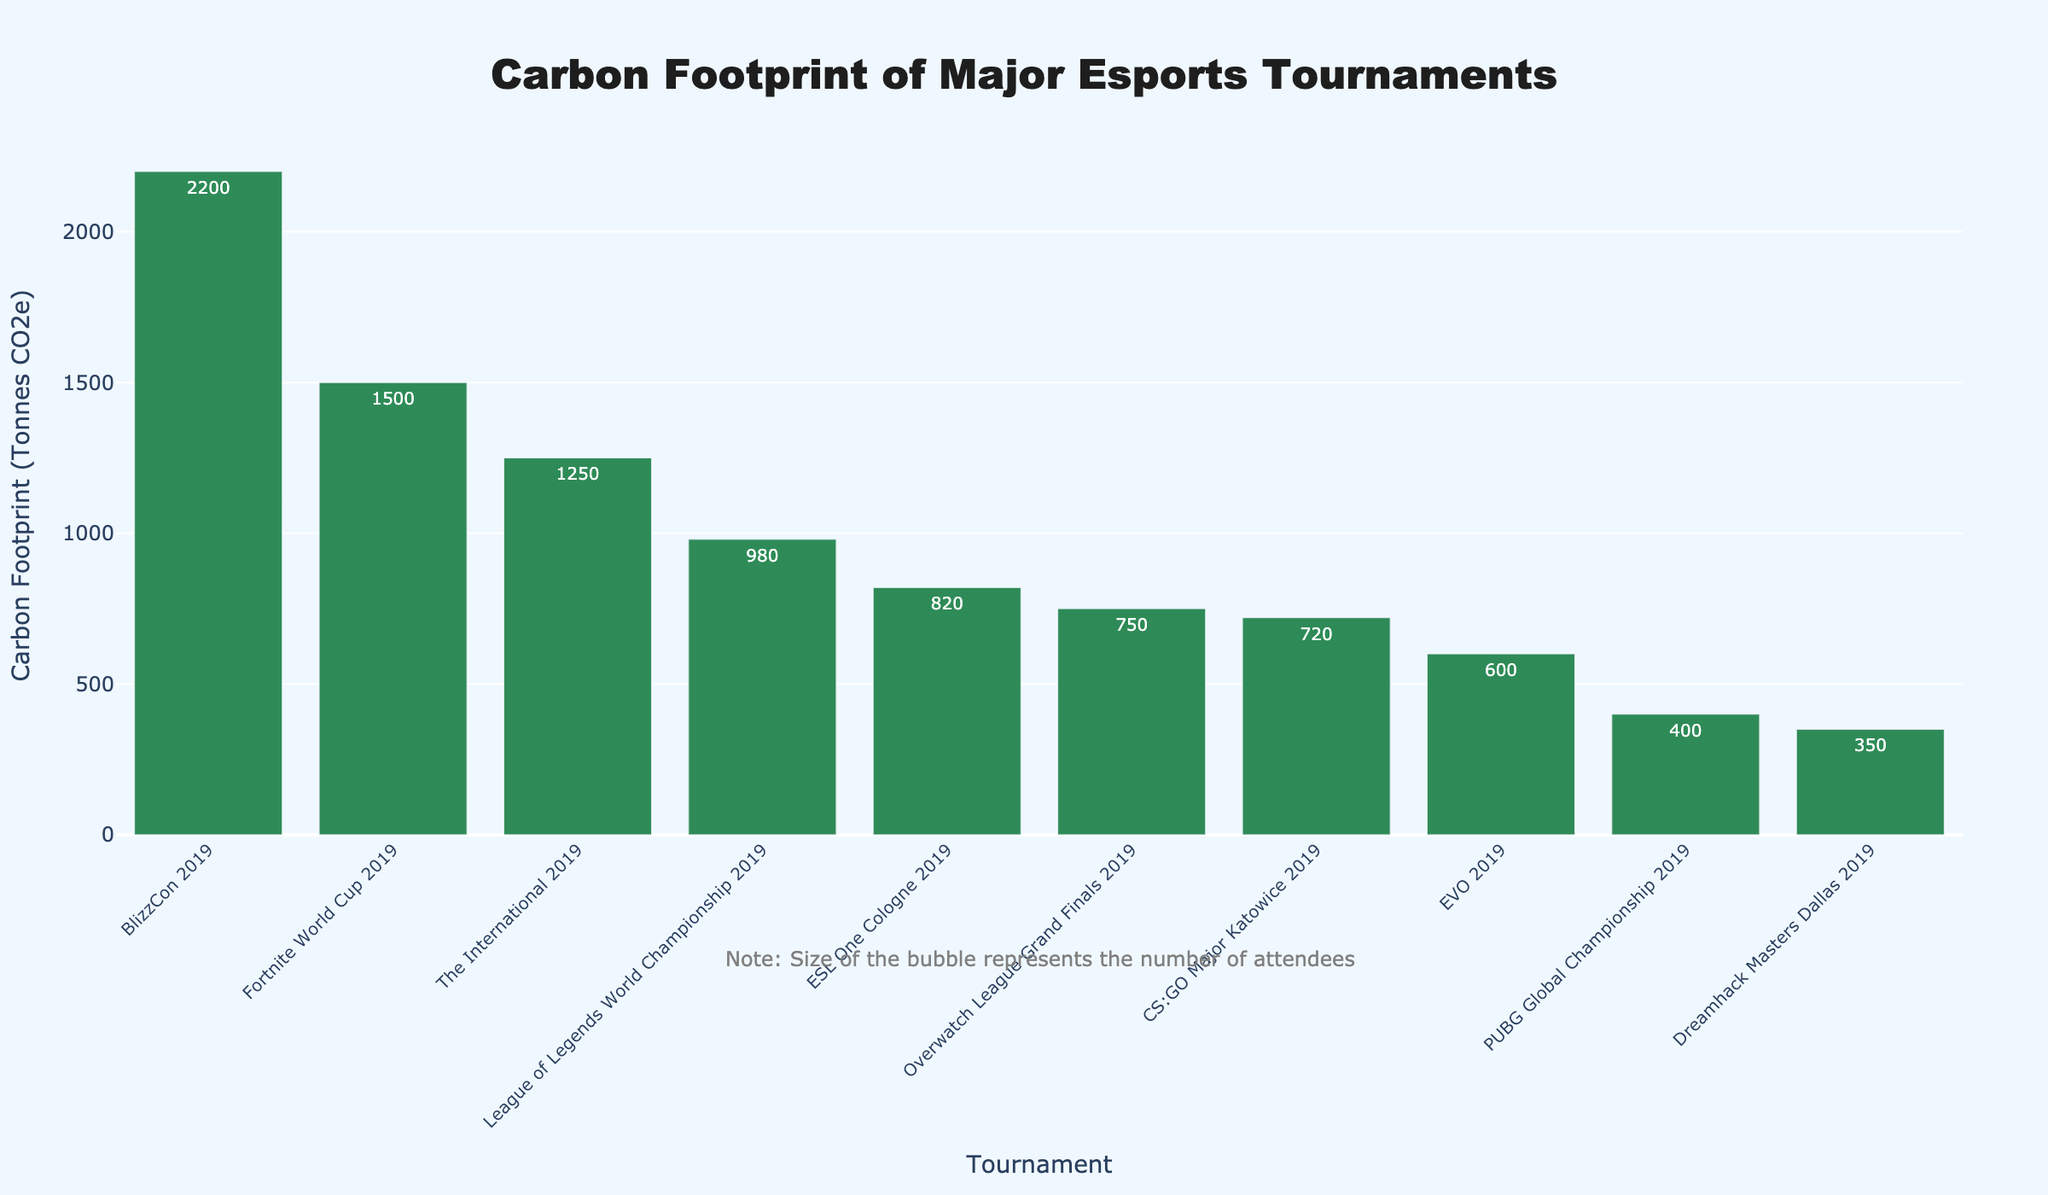Which event has the highest carbon footprint? The event with the highest carbon footprint is BlizzCon 2019, as its bar has the tallest height compared to others.
Answer: BlizzCon 2019 How many attendees were there at the event with the lowest carbon footprint? The event with the lowest carbon footprint is Dreamhack Masters Dallas 2019, which had 350 tonnes CO2e. According to the hover information, it had 5000 attendees.
Answer: 5000 What is the total carbon footprint of events with more than 10,000 attendees? We add the carbon footprints of events with more than 10,000 attendees: BlizzCon 2019 (2200), The International 2019 (1250), League of Legends World Championship 2019 (980), ESL One Cologne 2019 (820), Overwatch League Grand Finals 2019 (750), Fortnite World Cup 2019 (1500), CS:GO Major Katowice 2019 (720). The total sum is 8220 tonnes CO2e.
Answer: 8220 Which event had a higher carbon footprint: EVO 2019 or Overwatch League Grand Finals 2019? Comparing the bars, EVO 2019 had a carbon footprint of 600 tonnes CO2e and Overwatch League Grand Finals 2019 had 750 tonnes CO2e. Overwatch League Grand Finals 2019 had a higher carbon footprint.
Answer: Overwatch League Grand Finals 2019 What is the difference in carbon footprint between the event with the most attendees and the event with the fewest attendees? BlizzCon 2019 had the most attendees with 40,000 and a carbon footprint of 2200 tonnes CO2e. PUBG Global Championship 2019 had the fewest attendees with 6000 and a carbon footprint of 400 tonnes CO2e. The difference is 2200 - 400 = 1800 tonnes CO2e.
Answer: 1800 Which event has a greater carbon footprint relative to its attendees: ESL One Cologne 2019 or The International 2019? For ESL One Cologne 2019: 820 tonnes CO2e / 12000 attendees ≈ 0.0683 tonnes CO2e per attendee. For The International 2019: 1250 tonnes CO2e / 19000 attendees ≈ 0.0658 tonnes CO2e per attendee. ESL One Cologne 2019 has a greater carbon footprint relative to its attendees.
Answer: ESL One Cologne 2019 What is the average carbon footprint of all the events combined? The total carbon footprint of all events is (1250 + 980 + 820 + 600 + 750 + 1500 + 400 + 720 + 350 + 2200) = 9570 tonnes CO2e. There are 10 events. So, the average carbon footprint is 9570 / 10 = 957 tonnes CO2e.
Answer: 957 Which two events combined have a carbon footprint closest to 2000 tonnes CO2e? Considering different combinations: The International 2019 (1250) + EVO 2019 (600) = 1850, The International 2019 (1250) + Overwatch League Grand Finals 2019 (750) = 2000, League of Legends World Championship 2019 (980) + Overwatch League Grand Finals 2019 (750) = 1730, etc. The combination The International 2019 and Overwatch League Grand Finals 2019 results in exactly 2000 tonnes CO2e.
Answer: The International 2019 and Overwatch League Grand Finals 2019 